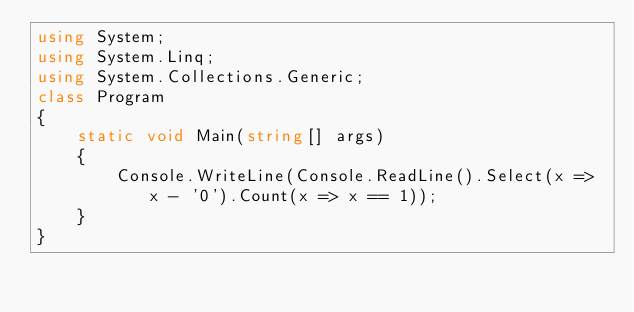Convert code to text. <code><loc_0><loc_0><loc_500><loc_500><_C#_>using System;
using System.Linq;
using System.Collections.Generic;
class Program
{
    static void Main(string[] args)
    {
        Console.WriteLine(Console.ReadLine().Select(x => x - '0').Count(x => x == 1));
    }
}
</code> 